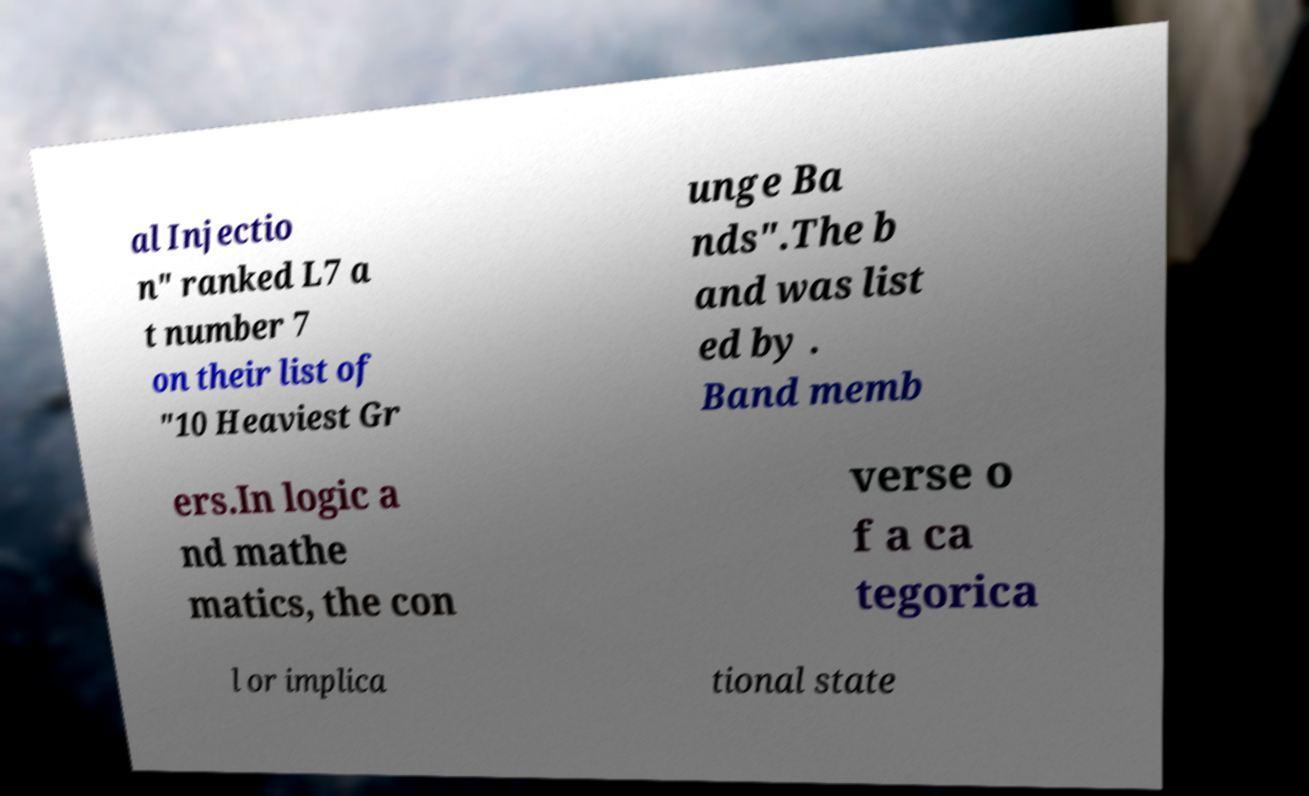For documentation purposes, I need the text within this image transcribed. Could you provide that? al Injectio n" ranked L7 a t number 7 on their list of "10 Heaviest Gr unge Ba nds".The b and was list ed by . Band memb ers.In logic a nd mathe matics, the con verse o f a ca tegorica l or implica tional state 